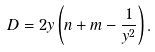<formula> <loc_0><loc_0><loc_500><loc_500>D = 2 y \left ( n + m - \frac { 1 } { y ^ { 2 } } \right ) .</formula> 